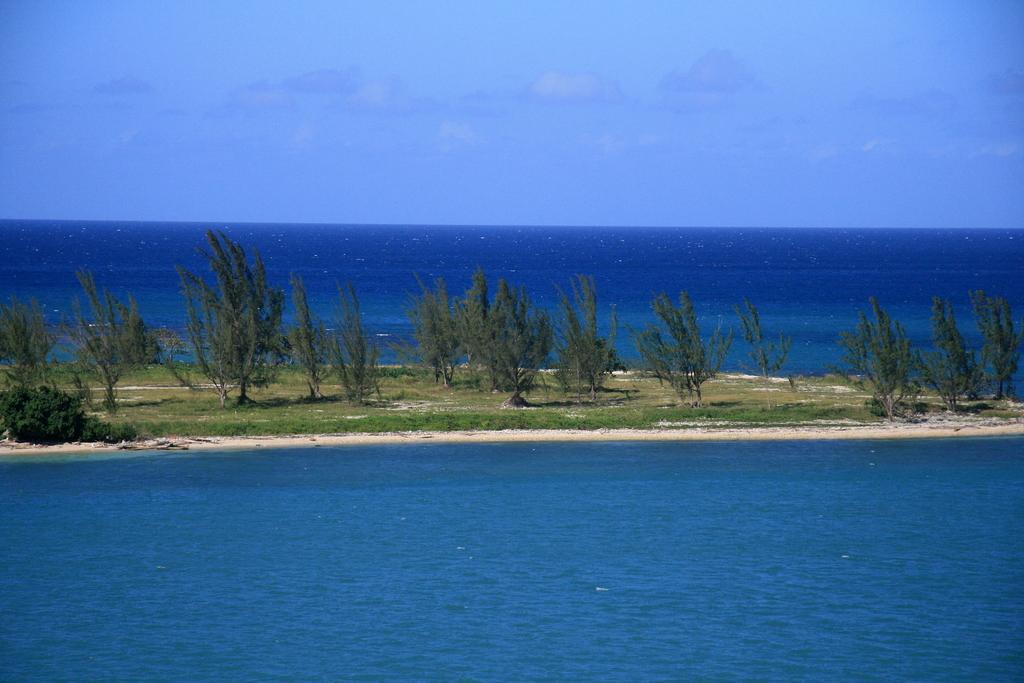What type of vegetation can be seen in the image? There are trees in the image. What can be seen in the background of the image? There is water visible in the background of the image. What is visible at the top of the image? The sky is visible at the top of the image. How many eggs are resting on the sheet in the image? There are no eggs or sheets present in the image; it features trees, water, and the sky. 